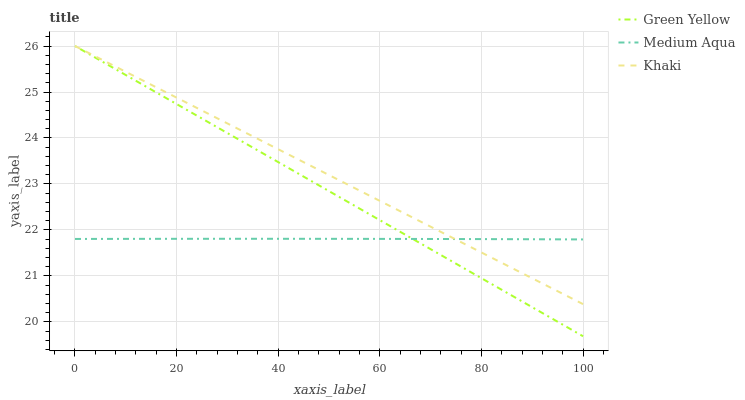Does Medium Aqua have the minimum area under the curve?
Answer yes or no. Yes. Does Khaki have the maximum area under the curve?
Answer yes or no. Yes. Does Khaki have the minimum area under the curve?
Answer yes or no. No. Does Medium Aqua have the maximum area under the curve?
Answer yes or no. No. Is Green Yellow the smoothest?
Answer yes or no. Yes. Is Medium Aqua the roughest?
Answer yes or no. Yes. Is Khaki the smoothest?
Answer yes or no. No. Is Khaki the roughest?
Answer yes or no. No. Does Khaki have the lowest value?
Answer yes or no. No. Does Khaki have the highest value?
Answer yes or no. Yes. Does Medium Aqua have the highest value?
Answer yes or no. No. Does Medium Aqua intersect Khaki?
Answer yes or no. Yes. Is Medium Aqua less than Khaki?
Answer yes or no. No. Is Medium Aqua greater than Khaki?
Answer yes or no. No. 